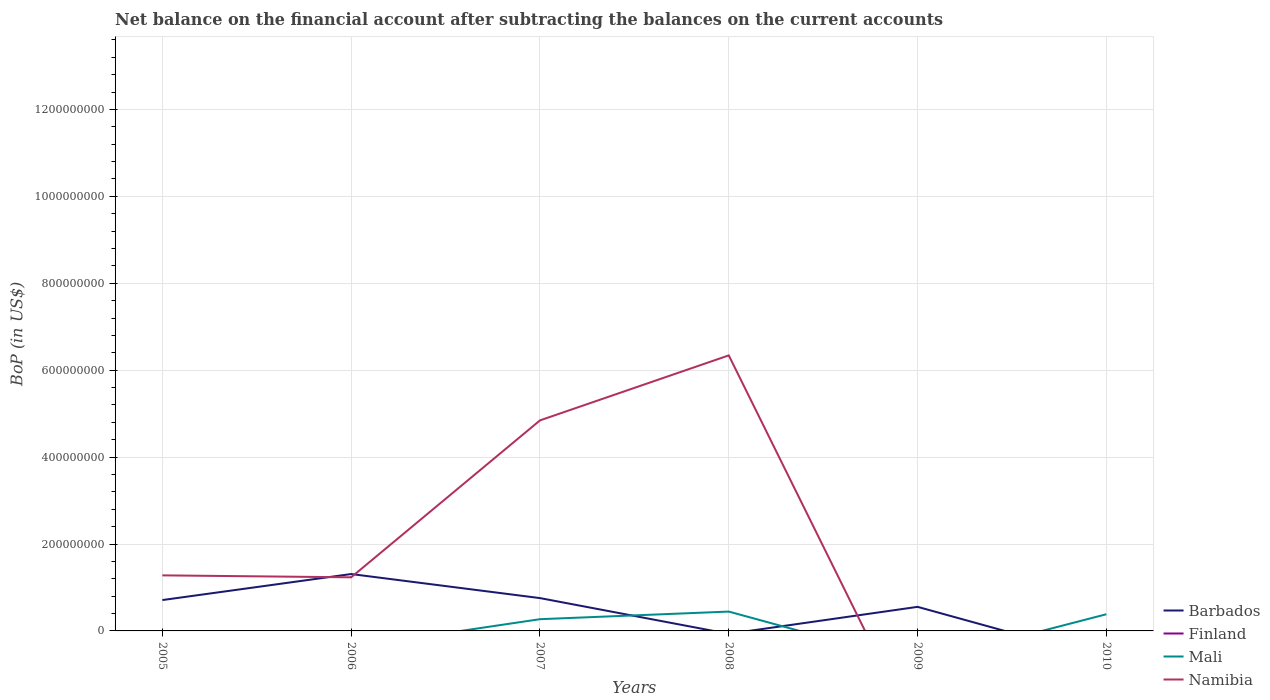Does the line corresponding to Namibia intersect with the line corresponding to Finland?
Keep it short and to the point. No. Is the number of lines equal to the number of legend labels?
Keep it short and to the point. No. What is the total Balance of Payments in Barbados in the graph?
Make the answer very short. 7.55e+07. What is the difference between the highest and the second highest Balance of Payments in Mali?
Offer a terse response. 4.45e+07. How many years are there in the graph?
Your answer should be compact. 6. What is the difference between two consecutive major ticks on the Y-axis?
Make the answer very short. 2.00e+08. Does the graph contain grids?
Keep it short and to the point. Yes. Where does the legend appear in the graph?
Your response must be concise. Bottom right. How many legend labels are there?
Provide a succinct answer. 4. What is the title of the graph?
Offer a very short reply. Net balance on the financial account after subtracting the balances on the current accounts. Does "Puerto Rico" appear as one of the legend labels in the graph?
Your answer should be compact. No. What is the label or title of the X-axis?
Offer a very short reply. Years. What is the label or title of the Y-axis?
Your response must be concise. BoP (in US$). What is the BoP (in US$) in Barbados in 2005?
Your answer should be compact. 7.10e+07. What is the BoP (in US$) in Namibia in 2005?
Your response must be concise. 1.28e+08. What is the BoP (in US$) of Barbados in 2006?
Provide a succinct answer. 1.31e+08. What is the BoP (in US$) in Finland in 2006?
Ensure brevity in your answer.  0. What is the BoP (in US$) of Mali in 2006?
Your answer should be very brief. 0. What is the BoP (in US$) in Namibia in 2006?
Offer a terse response. 1.23e+08. What is the BoP (in US$) in Barbados in 2007?
Ensure brevity in your answer.  7.55e+07. What is the BoP (in US$) in Mali in 2007?
Offer a terse response. 2.70e+07. What is the BoP (in US$) in Namibia in 2007?
Make the answer very short. 4.84e+08. What is the BoP (in US$) in Mali in 2008?
Give a very brief answer. 4.45e+07. What is the BoP (in US$) of Namibia in 2008?
Your response must be concise. 6.34e+08. What is the BoP (in US$) of Barbados in 2009?
Your answer should be very brief. 5.54e+07. What is the BoP (in US$) in Finland in 2009?
Provide a succinct answer. 0. What is the BoP (in US$) in Namibia in 2009?
Your answer should be compact. 0. What is the BoP (in US$) in Barbados in 2010?
Provide a short and direct response. 0. What is the BoP (in US$) of Mali in 2010?
Your answer should be very brief. 3.84e+07. What is the BoP (in US$) in Namibia in 2010?
Your response must be concise. 0. Across all years, what is the maximum BoP (in US$) in Barbados?
Provide a short and direct response. 1.31e+08. Across all years, what is the maximum BoP (in US$) of Mali?
Your answer should be compact. 4.45e+07. Across all years, what is the maximum BoP (in US$) in Namibia?
Provide a succinct answer. 6.34e+08. Across all years, what is the minimum BoP (in US$) in Barbados?
Offer a terse response. 0. Across all years, what is the minimum BoP (in US$) in Mali?
Your answer should be compact. 0. Across all years, what is the minimum BoP (in US$) in Namibia?
Your answer should be very brief. 0. What is the total BoP (in US$) in Barbados in the graph?
Provide a short and direct response. 3.33e+08. What is the total BoP (in US$) in Finland in the graph?
Ensure brevity in your answer.  0. What is the total BoP (in US$) in Mali in the graph?
Make the answer very short. 1.10e+08. What is the total BoP (in US$) of Namibia in the graph?
Your answer should be compact. 1.37e+09. What is the difference between the BoP (in US$) in Barbados in 2005 and that in 2006?
Your answer should be compact. -5.99e+07. What is the difference between the BoP (in US$) of Namibia in 2005 and that in 2006?
Offer a very short reply. 4.47e+06. What is the difference between the BoP (in US$) of Barbados in 2005 and that in 2007?
Ensure brevity in your answer.  -4.51e+06. What is the difference between the BoP (in US$) of Namibia in 2005 and that in 2007?
Provide a short and direct response. -3.57e+08. What is the difference between the BoP (in US$) in Namibia in 2005 and that in 2008?
Provide a succinct answer. -5.06e+08. What is the difference between the BoP (in US$) of Barbados in 2005 and that in 2009?
Make the answer very short. 1.56e+07. What is the difference between the BoP (in US$) of Barbados in 2006 and that in 2007?
Your response must be concise. 5.54e+07. What is the difference between the BoP (in US$) in Namibia in 2006 and that in 2007?
Keep it short and to the point. -3.61e+08. What is the difference between the BoP (in US$) in Namibia in 2006 and that in 2008?
Ensure brevity in your answer.  -5.11e+08. What is the difference between the BoP (in US$) of Barbados in 2006 and that in 2009?
Your answer should be very brief. 7.55e+07. What is the difference between the BoP (in US$) of Mali in 2007 and that in 2008?
Ensure brevity in your answer.  -1.75e+07. What is the difference between the BoP (in US$) of Namibia in 2007 and that in 2008?
Your response must be concise. -1.50e+08. What is the difference between the BoP (in US$) of Barbados in 2007 and that in 2009?
Give a very brief answer. 2.01e+07. What is the difference between the BoP (in US$) of Mali in 2007 and that in 2010?
Provide a succinct answer. -1.14e+07. What is the difference between the BoP (in US$) in Mali in 2008 and that in 2010?
Offer a terse response. 6.10e+06. What is the difference between the BoP (in US$) of Barbados in 2005 and the BoP (in US$) of Namibia in 2006?
Your response must be concise. -5.24e+07. What is the difference between the BoP (in US$) in Barbados in 2005 and the BoP (in US$) in Mali in 2007?
Your answer should be compact. 4.40e+07. What is the difference between the BoP (in US$) in Barbados in 2005 and the BoP (in US$) in Namibia in 2007?
Give a very brief answer. -4.13e+08. What is the difference between the BoP (in US$) of Barbados in 2005 and the BoP (in US$) of Mali in 2008?
Ensure brevity in your answer.  2.65e+07. What is the difference between the BoP (in US$) in Barbados in 2005 and the BoP (in US$) in Namibia in 2008?
Give a very brief answer. -5.63e+08. What is the difference between the BoP (in US$) in Barbados in 2005 and the BoP (in US$) in Mali in 2010?
Offer a very short reply. 3.26e+07. What is the difference between the BoP (in US$) in Barbados in 2006 and the BoP (in US$) in Mali in 2007?
Offer a very short reply. 1.04e+08. What is the difference between the BoP (in US$) of Barbados in 2006 and the BoP (in US$) of Namibia in 2007?
Your answer should be very brief. -3.54e+08. What is the difference between the BoP (in US$) of Barbados in 2006 and the BoP (in US$) of Mali in 2008?
Offer a very short reply. 8.64e+07. What is the difference between the BoP (in US$) of Barbados in 2006 and the BoP (in US$) of Namibia in 2008?
Make the answer very short. -5.03e+08. What is the difference between the BoP (in US$) in Barbados in 2006 and the BoP (in US$) in Mali in 2010?
Your response must be concise. 9.25e+07. What is the difference between the BoP (in US$) in Barbados in 2007 and the BoP (in US$) in Mali in 2008?
Keep it short and to the point. 3.10e+07. What is the difference between the BoP (in US$) in Barbados in 2007 and the BoP (in US$) in Namibia in 2008?
Make the answer very short. -5.58e+08. What is the difference between the BoP (in US$) in Mali in 2007 and the BoP (in US$) in Namibia in 2008?
Keep it short and to the point. -6.07e+08. What is the difference between the BoP (in US$) of Barbados in 2007 and the BoP (in US$) of Mali in 2010?
Your answer should be very brief. 3.71e+07. What is the difference between the BoP (in US$) of Barbados in 2009 and the BoP (in US$) of Mali in 2010?
Keep it short and to the point. 1.70e+07. What is the average BoP (in US$) in Barbados per year?
Your response must be concise. 5.55e+07. What is the average BoP (in US$) in Finland per year?
Your response must be concise. 0. What is the average BoP (in US$) of Mali per year?
Offer a very short reply. 1.83e+07. What is the average BoP (in US$) of Namibia per year?
Your answer should be compact. 2.28e+08. In the year 2005, what is the difference between the BoP (in US$) in Barbados and BoP (in US$) in Namibia?
Keep it short and to the point. -5.68e+07. In the year 2006, what is the difference between the BoP (in US$) of Barbados and BoP (in US$) of Namibia?
Offer a terse response. 7.52e+06. In the year 2007, what is the difference between the BoP (in US$) in Barbados and BoP (in US$) in Mali?
Ensure brevity in your answer.  4.85e+07. In the year 2007, what is the difference between the BoP (in US$) in Barbados and BoP (in US$) in Namibia?
Ensure brevity in your answer.  -4.09e+08. In the year 2007, what is the difference between the BoP (in US$) of Mali and BoP (in US$) of Namibia?
Your answer should be compact. -4.57e+08. In the year 2008, what is the difference between the BoP (in US$) of Mali and BoP (in US$) of Namibia?
Offer a terse response. -5.89e+08. What is the ratio of the BoP (in US$) of Barbados in 2005 to that in 2006?
Your response must be concise. 0.54. What is the ratio of the BoP (in US$) of Namibia in 2005 to that in 2006?
Your answer should be very brief. 1.04. What is the ratio of the BoP (in US$) in Barbados in 2005 to that in 2007?
Your response must be concise. 0.94. What is the ratio of the BoP (in US$) of Namibia in 2005 to that in 2007?
Give a very brief answer. 0.26. What is the ratio of the BoP (in US$) in Namibia in 2005 to that in 2008?
Make the answer very short. 0.2. What is the ratio of the BoP (in US$) of Barbados in 2005 to that in 2009?
Provide a succinct answer. 1.28. What is the ratio of the BoP (in US$) of Barbados in 2006 to that in 2007?
Give a very brief answer. 1.73. What is the ratio of the BoP (in US$) in Namibia in 2006 to that in 2007?
Offer a terse response. 0.25. What is the ratio of the BoP (in US$) in Namibia in 2006 to that in 2008?
Offer a very short reply. 0.19. What is the ratio of the BoP (in US$) of Barbados in 2006 to that in 2009?
Give a very brief answer. 2.36. What is the ratio of the BoP (in US$) in Mali in 2007 to that in 2008?
Your answer should be very brief. 0.61. What is the ratio of the BoP (in US$) of Namibia in 2007 to that in 2008?
Your response must be concise. 0.76. What is the ratio of the BoP (in US$) in Barbados in 2007 to that in 2009?
Ensure brevity in your answer.  1.36. What is the ratio of the BoP (in US$) of Mali in 2007 to that in 2010?
Your response must be concise. 0.7. What is the ratio of the BoP (in US$) in Mali in 2008 to that in 2010?
Keep it short and to the point. 1.16. What is the difference between the highest and the second highest BoP (in US$) in Barbados?
Your answer should be compact. 5.54e+07. What is the difference between the highest and the second highest BoP (in US$) of Mali?
Your answer should be compact. 6.10e+06. What is the difference between the highest and the second highest BoP (in US$) of Namibia?
Give a very brief answer. 1.50e+08. What is the difference between the highest and the lowest BoP (in US$) of Barbados?
Offer a very short reply. 1.31e+08. What is the difference between the highest and the lowest BoP (in US$) of Mali?
Ensure brevity in your answer.  4.45e+07. What is the difference between the highest and the lowest BoP (in US$) of Namibia?
Your answer should be compact. 6.34e+08. 